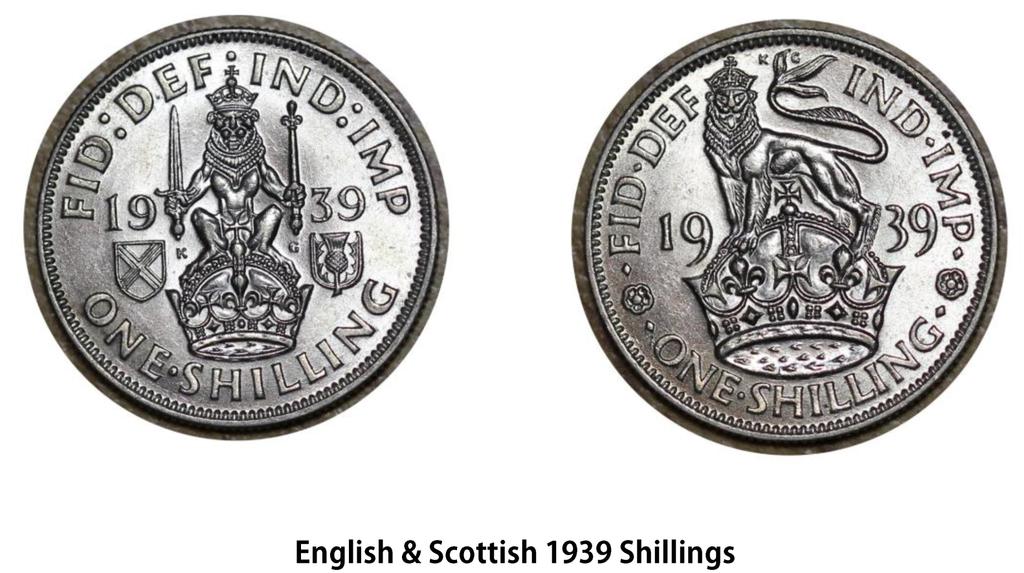How old are these coins?
Your response must be concise. 1939. Are these coins english and scottish?
Keep it short and to the point. Yes. 